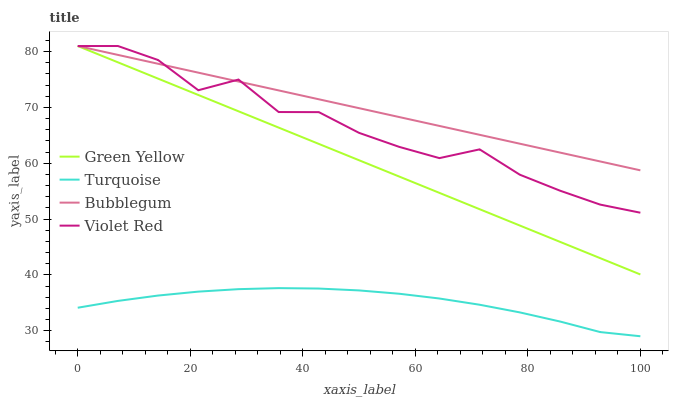Does Turquoise have the minimum area under the curve?
Answer yes or no. Yes. Does Bubblegum have the maximum area under the curve?
Answer yes or no. Yes. Does Green Yellow have the minimum area under the curve?
Answer yes or no. No. Does Green Yellow have the maximum area under the curve?
Answer yes or no. No. Is Bubblegum the smoothest?
Answer yes or no. Yes. Is Violet Red the roughest?
Answer yes or no. Yes. Is Green Yellow the smoothest?
Answer yes or no. No. Is Green Yellow the roughest?
Answer yes or no. No. Does Turquoise have the lowest value?
Answer yes or no. Yes. Does Green Yellow have the lowest value?
Answer yes or no. No. Does Bubblegum have the highest value?
Answer yes or no. Yes. Is Turquoise less than Bubblegum?
Answer yes or no. Yes. Is Green Yellow greater than Turquoise?
Answer yes or no. Yes. Does Bubblegum intersect Green Yellow?
Answer yes or no. Yes. Is Bubblegum less than Green Yellow?
Answer yes or no. No. Is Bubblegum greater than Green Yellow?
Answer yes or no. No. Does Turquoise intersect Bubblegum?
Answer yes or no. No. 